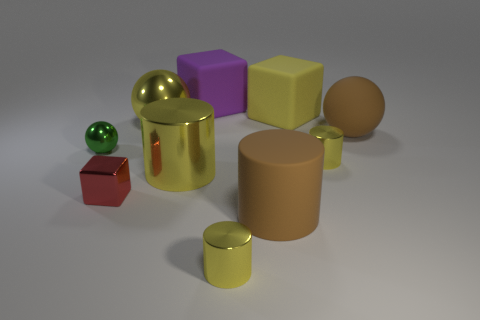What number of other objects are the same shape as the green metallic thing?
Give a very brief answer. 2. How many things are small objects that are on the right side of the big yellow shiny sphere or big matte objects that are left of the big brown rubber sphere?
Offer a very short reply. 5. How many other objects are the same color as the tiny cube?
Ensure brevity in your answer.  0. Are there fewer tiny yellow shiny things behind the brown cylinder than shiny cylinders behind the small red cube?
Keep it short and to the point. Yes. What number of blue matte cylinders are there?
Offer a very short reply. 0. What is the material of the large yellow thing that is the same shape as the tiny green shiny object?
Your response must be concise. Metal. Are there fewer big yellow metal spheres that are in front of the large yellow shiny ball than large objects?
Your answer should be compact. Yes. There is a large metallic object behind the tiny green thing; is its shape the same as the tiny green shiny thing?
Offer a very short reply. Yes. Is there anything else that is the same color as the large shiny cylinder?
Offer a very short reply. Yes. What size is the red object that is made of the same material as the green ball?
Make the answer very short. Small. 